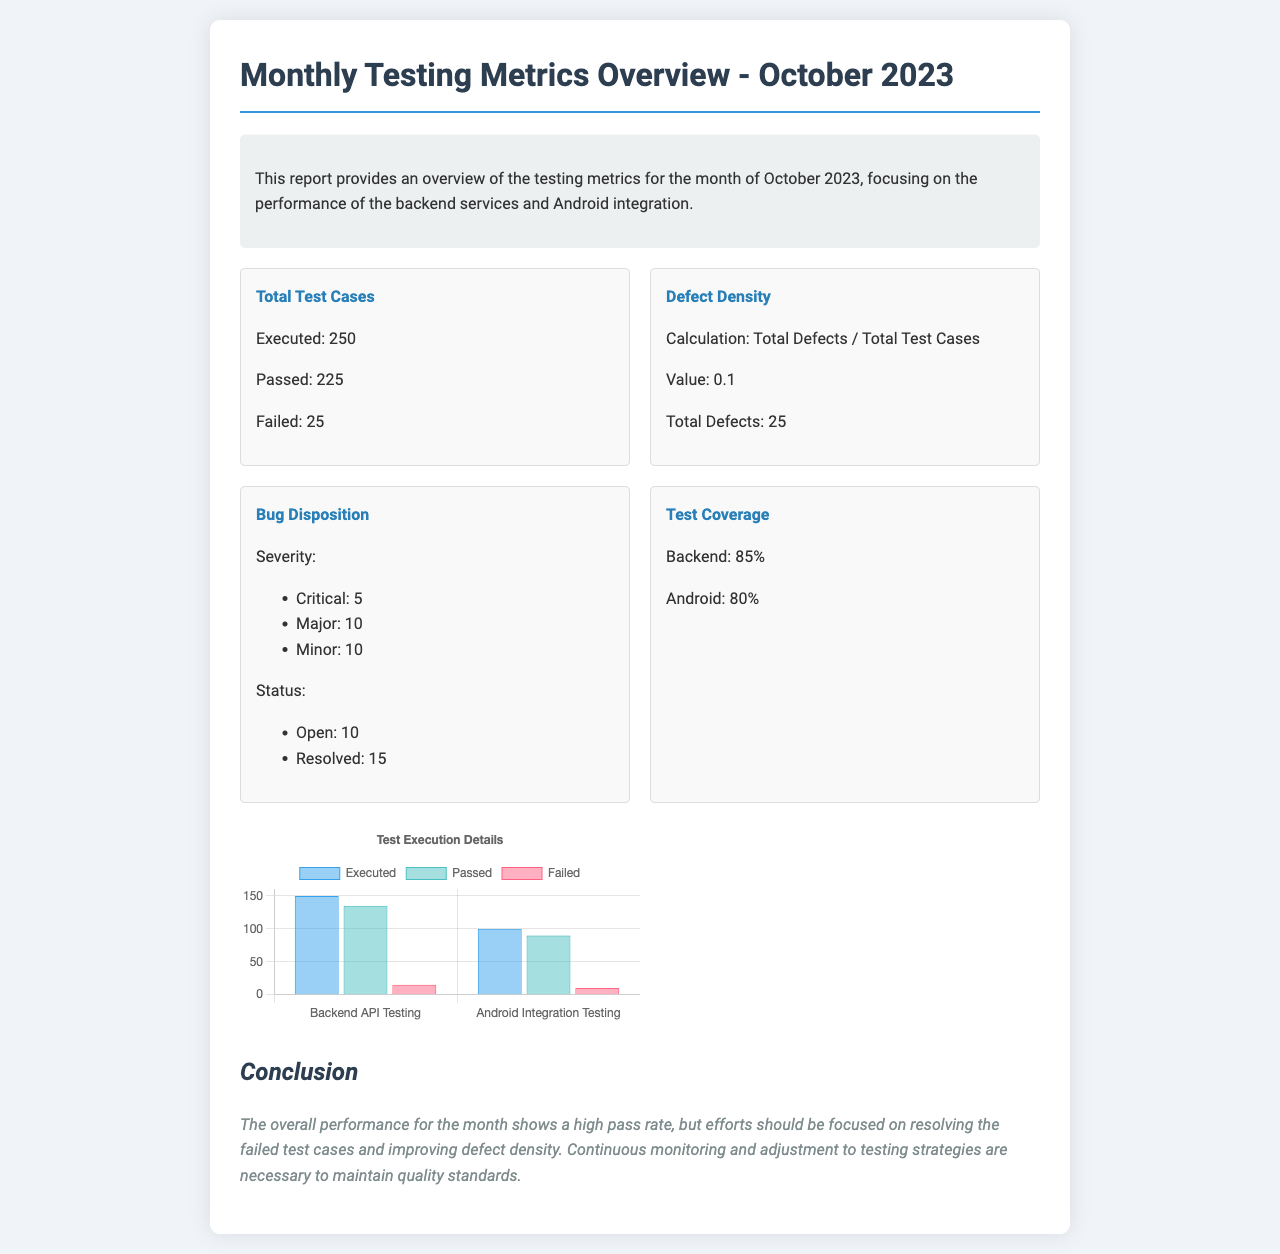What is the total number of test cases executed? The total number of test cases executed is mentioned in the document as 250.
Answer: 250 How many test cases passed? The number of test cases that passed according to the document is provided as 225.
Answer: 225 What is the defect density value? The defect density value is calculated as total defects divided by total test cases, which is stated in the document as 0.1.
Answer: 0.1 How many critical bugs were reported? The document lists the number of critical bugs reported as 5.
Answer: 5 What is the test coverage percentage for Android? The test coverage percentage for Android is mentioned in the document as 80%.
Answer: 80% How many test cases failed? The total number of test cases that failed according to the document is stated as 25.
Answer: 25 What percentage of test coverage is reported for the backend? The percentage of test coverage for the backend is provided as 85% in the document.
Answer: 85% What is the total number of open defects? The document indicates that the total number of open defects is 10.
Answer: 10 How many major bugs are reported? The document specifies the number of major bugs reported as 10.
Answer: 10 